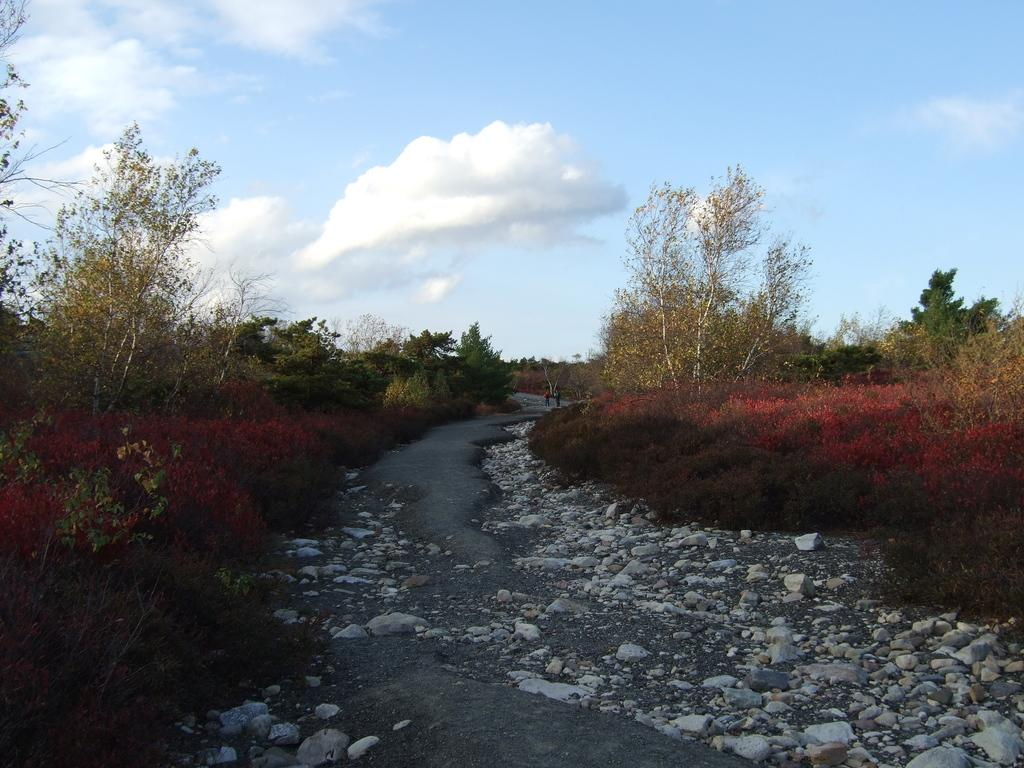What is the main feature of the image? There is a path or road in the image. What can be seen alongside the path or road? Rocks are present along the path or road, and there are plants and trees on both sides. Are there any plants with a specific color in the image? Yes, some plants are in red color. What is visible in the sky in the image? There are clouds visible in the sky. What type of canvas is being used to capture the image? The image is not a painting on canvas; it is a photograph or digital image. What camera settings were used to take the image? The provided facts do not include information about the camera settings used to take the image. 